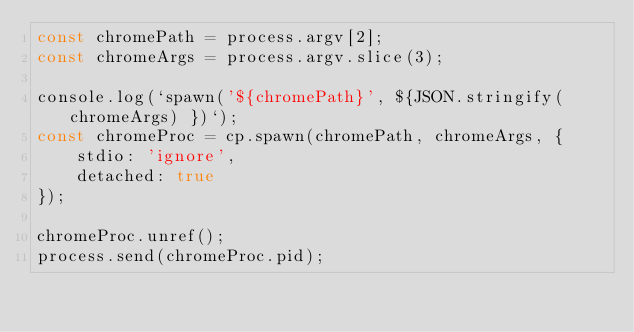Convert code to text. <code><loc_0><loc_0><loc_500><loc_500><_TypeScript_>const chromePath = process.argv[2];
const chromeArgs = process.argv.slice(3);

console.log(`spawn('${chromePath}', ${JSON.stringify(chromeArgs) })`);
const chromeProc = cp.spawn(chromePath, chromeArgs, {
    stdio: 'ignore',
    detached: true
});

chromeProc.unref();
process.send(chromeProc.pid);
</code> 